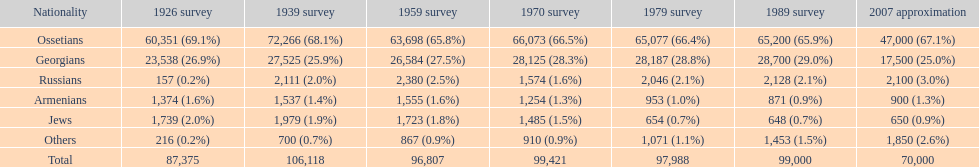Which population had the most people in 1926? Ossetians. 